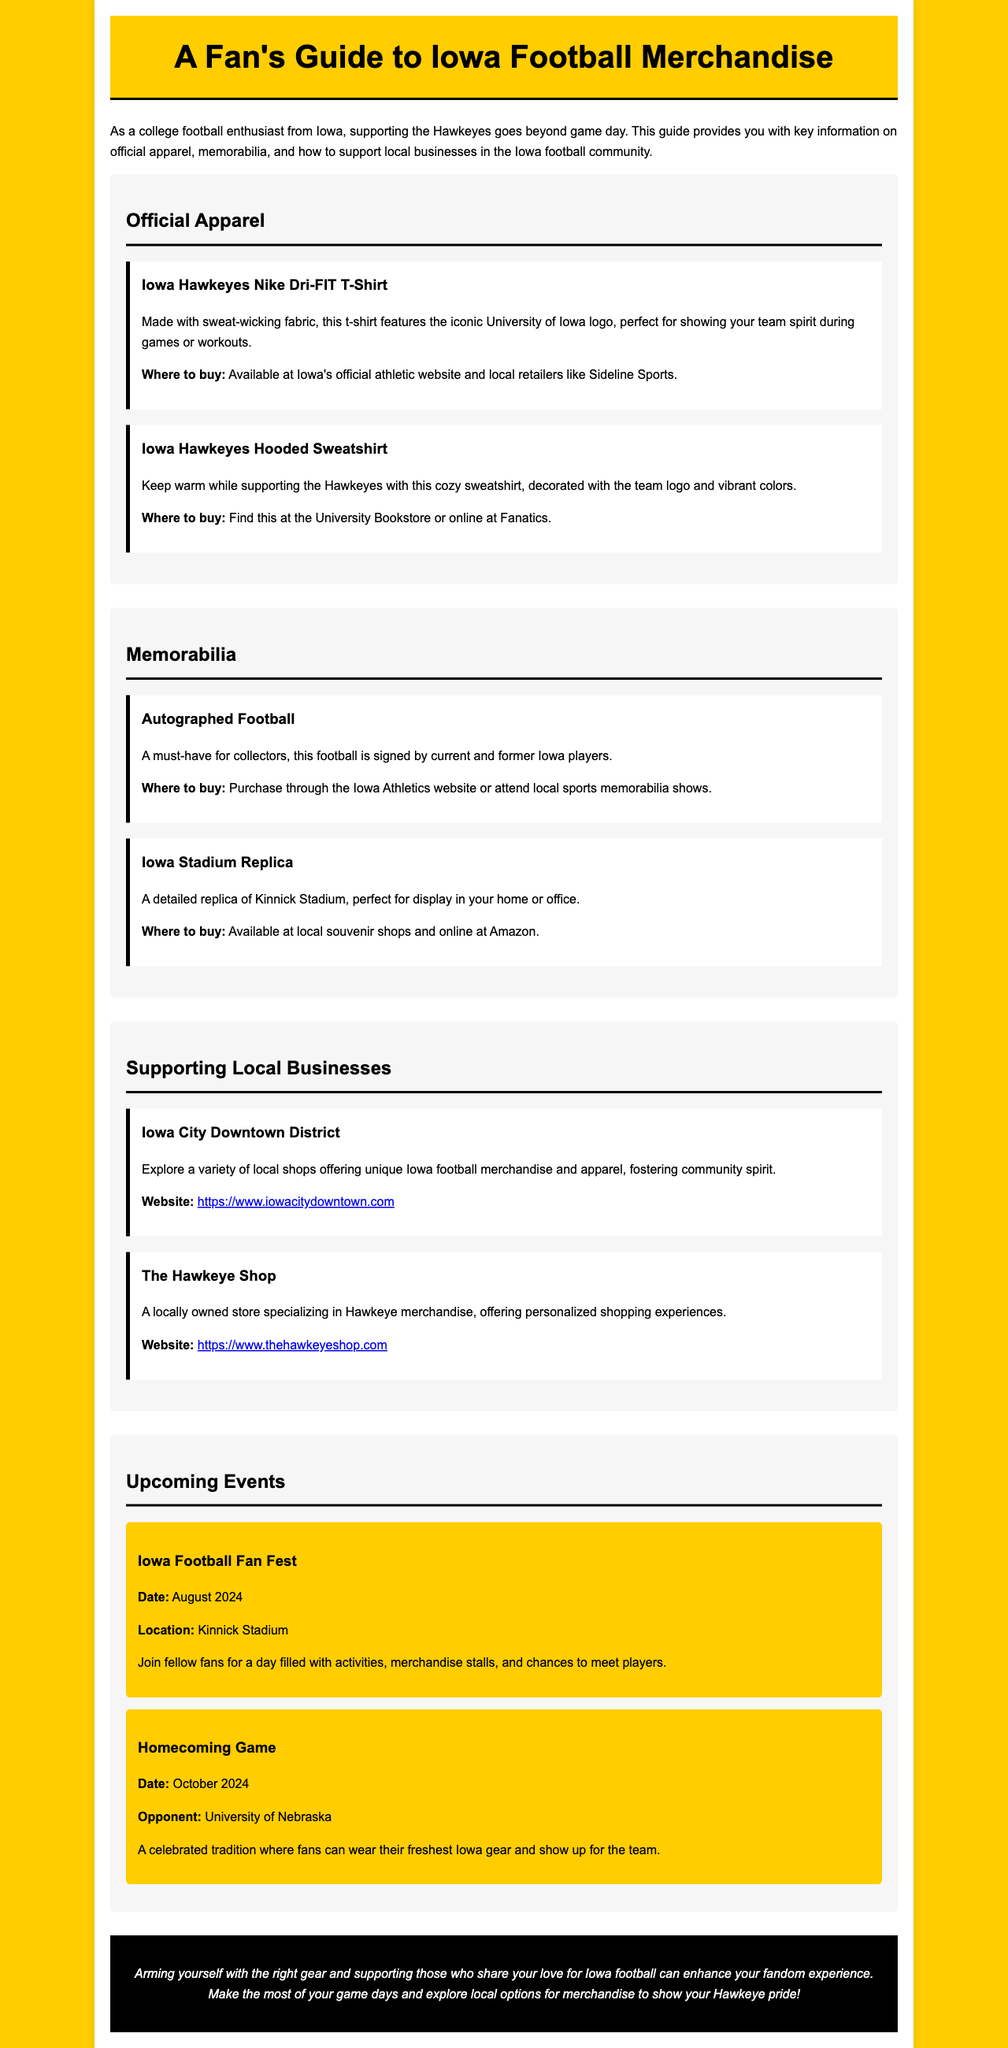what is the title of the guide? The title of the guide is displayed at the top of the document, introducing the content.
Answer: A Fan's Guide to Iowa Football Merchandise what type of t-shirt is mentioned? The document specifies the style of t-shirt that is available for purchase.
Answer: Nike Dri-FIT T-Shirt where can you buy the Iowa Hawkeyes Hooded Sweatshirt? The document provides specific locations where the sweatshirt can be purchased.
Answer: University Bookstore or online at Fanatics what is a must-have item for collectors? The document highlights an item that is essential for enthusiasts who collect memorabilia.
Answer: Autographed Football which local shop specializes in Hawkeye merchandise? The guide lists a specific local store that focuses on Iowa football products.
Answer: The Hawkeye Shop when is the Iowa Football Fan Fest scheduled? The document includes the date of an upcoming event for fans of the team.
Answer: August 2024 what is included in the document to support local businesses? The guide discusses a specific area and a local store to help fans shop locally.
Answer: Iowa City Downtown District what color is the background of the document? The document describes the overall design and colors used in the layout.
Answer: #FFCD00 where can you find a detailed replica of Kinnick Stadium? This question references the location where a specific item can be acquired, as stated in the document.
Answer: Local souvenir shops and online at Amazon 